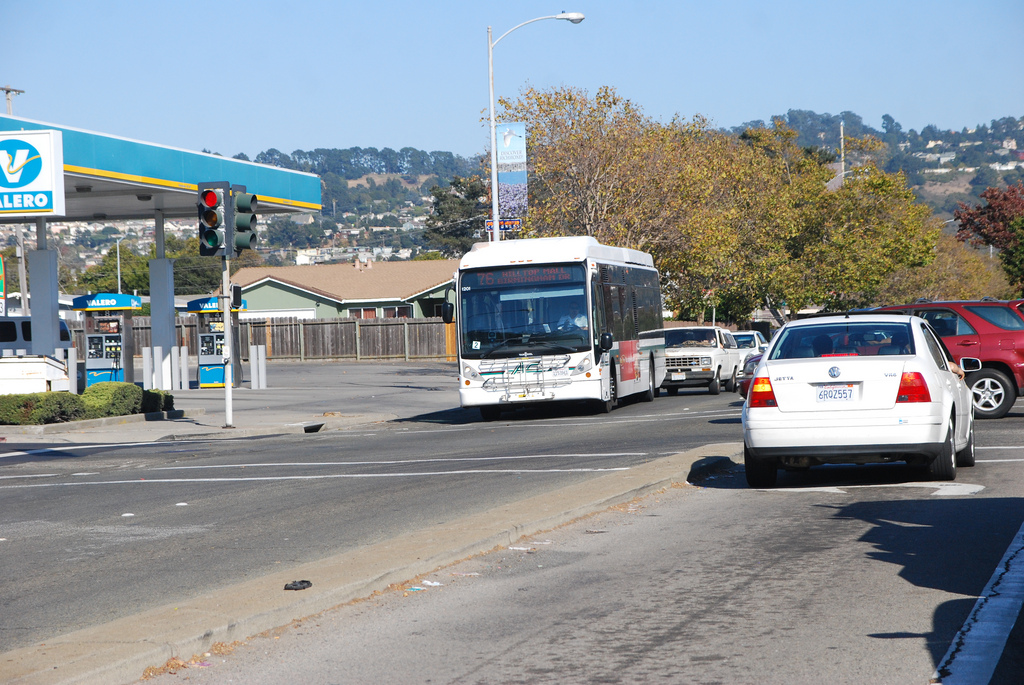How is the vehicle to the right of the person that is to the right of the fence called? The vehicle to the right of the pedestrian, who is to the right of the wooden fence, is a white car. 